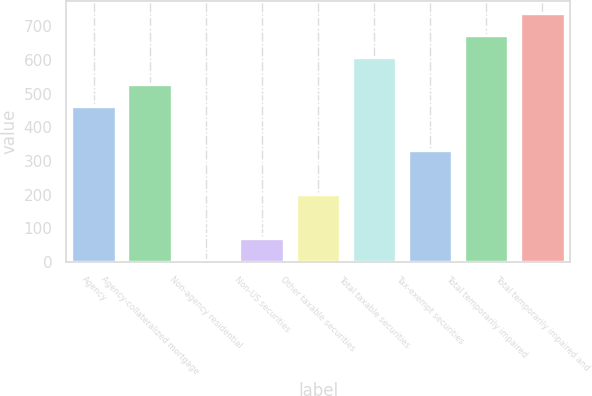<chart> <loc_0><loc_0><loc_500><loc_500><bar_chart><fcel>Agency<fcel>Agency-collateralized mortgage<fcel>Non-agency residential<fcel>Non-US securities<fcel>Other taxable securities<fcel>Total taxable securities<fcel>Tax-exempt securities<fcel>Total temporarily impaired<fcel>Total temporarily impaired and<nl><fcel>463.5<fcel>529<fcel>5<fcel>70.5<fcel>201.5<fcel>608<fcel>332.5<fcel>673.5<fcel>739<nl></chart> 